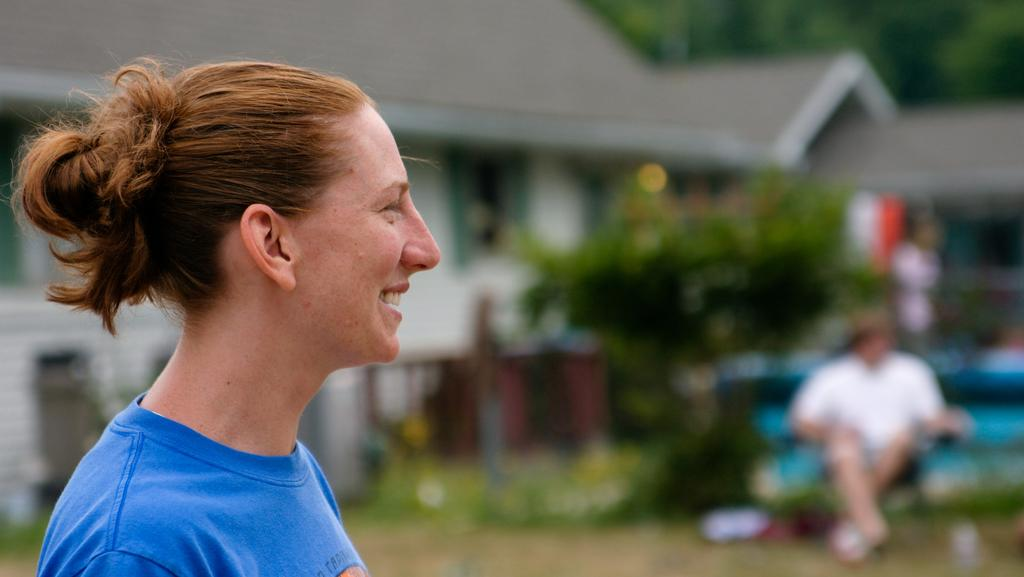Who is the main subject in the image? There is a person in the front of the image. What is the person doing in the image? The person is smiling. What can be seen in the background of the image? There are trees and a building in the background of the image. Are there any other people visible in the image? Yes, there are other persons in the background of the image. What type of wing can be seen flying in the image? There is no wing or any flying object present in the image. Can you describe the coastline visible in the image? There is no coastline visible in the image; it features a person, trees, a building, and other people. 